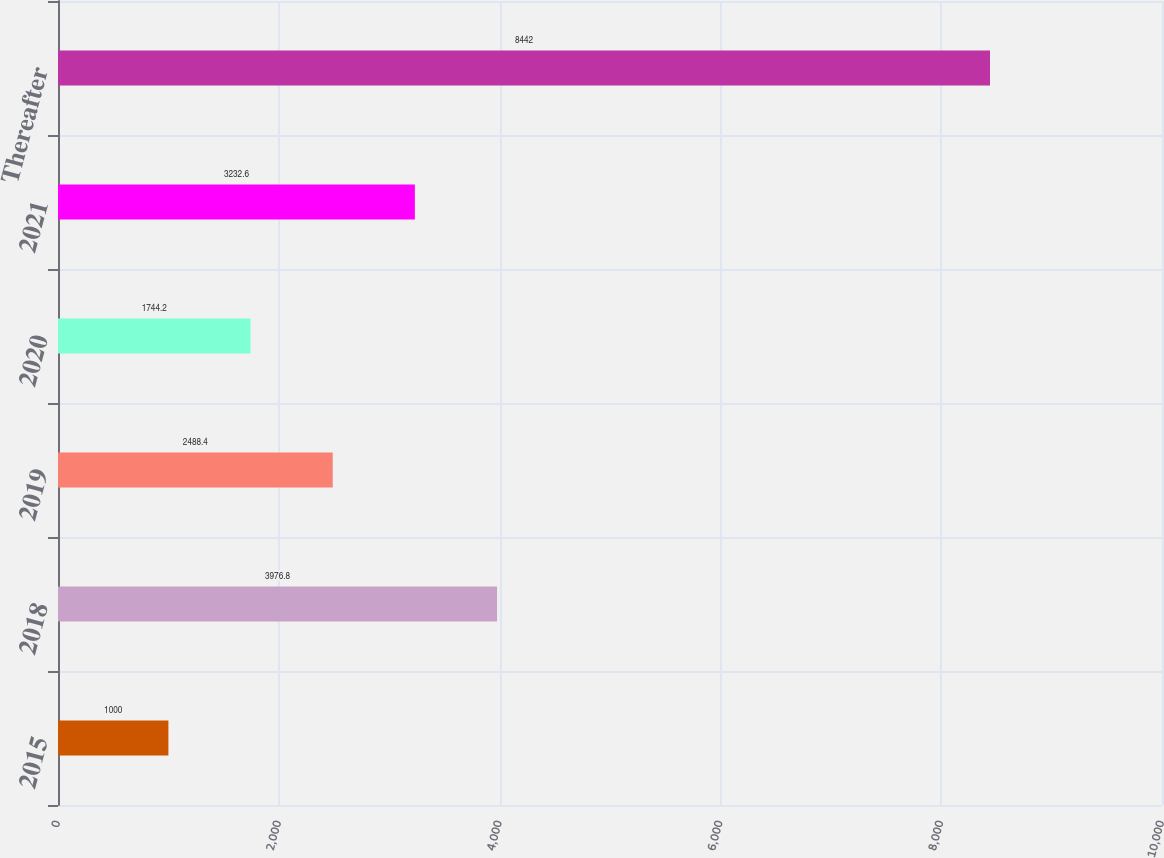Convert chart to OTSL. <chart><loc_0><loc_0><loc_500><loc_500><bar_chart><fcel>2015<fcel>2018<fcel>2019<fcel>2020<fcel>2021<fcel>Thereafter<nl><fcel>1000<fcel>3976.8<fcel>2488.4<fcel>1744.2<fcel>3232.6<fcel>8442<nl></chart> 